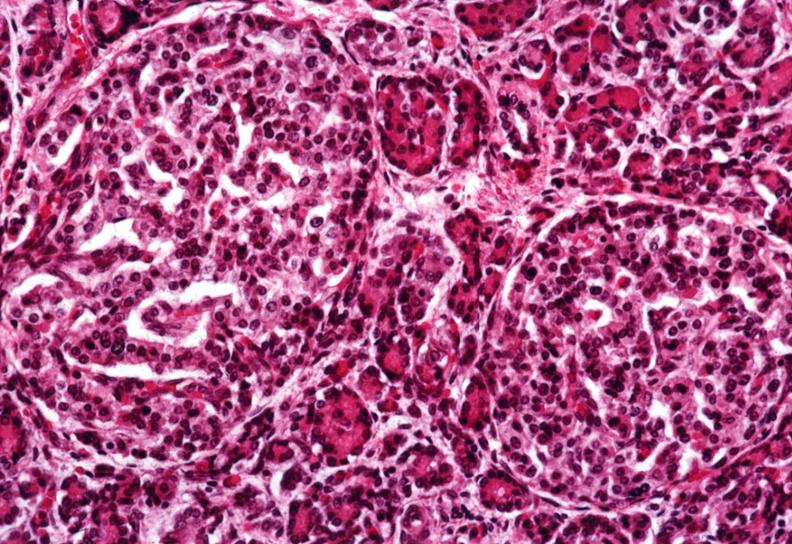what does this image show?
Answer the question using a single word or phrase. Two quite large islets 